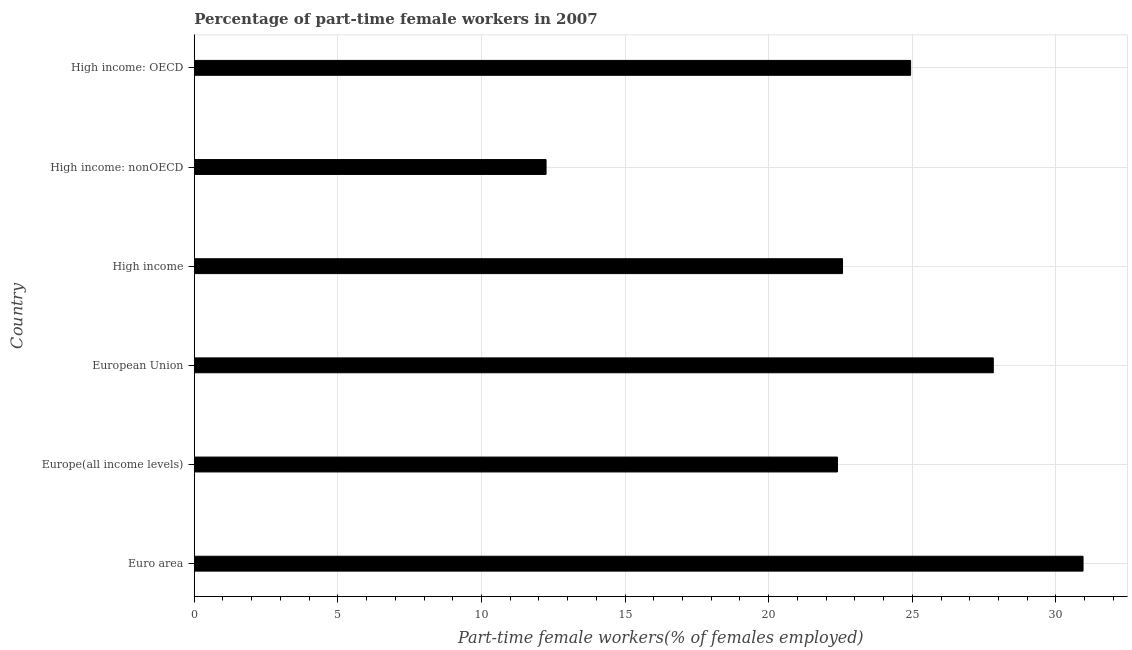Does the graph contain any zero values?
Make the answer very short. No. What is the title of the graph?
Make the answer very short. Percentage of part-time female workers in 2007. What is the label or title of the X-axis?
Your answer should be compact. Part-time female workers(% of females employed). What is the label or title of the Y-axis?
Ensure brevity in your answer.  Country. What is the percentage of part-time female workers in Euro area?
Your response must be concise. 30.95. Across all countries, what is the maximum percentage of part-time female workers?
Ensure brevity in your answer.  30.95. Across all countries, what is the minimum percentage of part-time female workers?
Provide a short and direct response. 12.25. In which country was the percentage of part-time female workers maximum?
Make the answer very short. Euro area. In which country was the percentage of part-time female workers minimum?
Provide a short and direct response. High income: nonOECD. What is the sum of the percentage of part-time female workers?
Make the answer very short. 140.92. What is the difference between the percentage of part-time female workers in Europe(all income levels) and High income: OECD?
Keep it short and to the point. -2.55. What is the average percentage of part-time female workers per country?
Keep it short and to the point. 23.49. What is the median percentage of part-time female workers?
Your answer should be compact. 23.76. What is the ratio of the percentage of part-time female workers in High income to that in High income: nonOECD?
Keep it short and to the point. 1.84. Is the percentage of part-time female workers in Euro area less than that in High income?
Make the answer very short. No. Is the difference between the percentage of part-time female workers in High income and High income: nonOECD greater than the difference between any two countries?
Your response must be concise. No. What is the difference between the highest and the second highest percentage of part-time female workers?
Provide a short and direct response. 3.12. Is the sum of the percentage of part-time female workers in High income and High income: nonOECD greater than the maximum percentage of part-time female workers across all countries?
Make the answer very short. Yes. In how many countries, is the percentage of part-time female workers greater than the average percentage of part-time female workers taken over all countries?
Your answer should be compact. 3. How many bars are there?
Offer a very short reply. 6. Are all the bars in the graph horizontal?
Give a very brief answer. Yes. What is the Part-time female workers(% of females employed) of Euro area?
Give a very brief answer. 30.95. What is the Part-time female workers(% of females employed) of Europe(all income levels)?
Provide a short and direct response. 22.39. What is the Part-time female workers(% of females employed) in European Union?
Ensure brevity in your answer.  27.82. What is the Part-time female workers(% of females employed) of High income?
Offer a very short reply. 22.57. What is the Part-time female workers(% of females employed) of High income: nonOECD?
Provide a succinct answer. 12.25. What is the Part-time female workers(% of females employed) in High income: OECD?
Ensure brevity in your answer.  24.94. What is the difference between the Part-time female workers(% of females employed) in Euro area and Europe(all income levels)?
Offer a very short reply. 8.55. What is the difference between the Part-time female workers(% of females employed) in Euro area and European Union?
Your answer should be compact. 3.13. What is the difference between the Part-time female workers(% of females employed) in Euro area and High income?
Provide a succinct answer. 8.37. What is the difference between the Part-time female workers(% of females employed) in Euro area and High income: nonOECD?
Give a very brief answer. 18.7. What is the difference between the Part-time female workers(% of females employed) in Euro area and High income: OECD?
Your answer should be compact. 6. What is the difference between the Part-time female workers(% of females employed) in Europe(all income levels) and European Union?
Ensure brevity in your answer.  -5.43. What is the difference between the Part-time female workers(% of females employed) in Europe(all income levels) and High income?
Provide a succinct answer. -0.18. What is the difference between the Part-time female workers(% of females employed) in Europe(all income levels) and High income: nonOECD?
Your response must be concise. 10.15. What is the difference between the Part-time female workers(% of females employed) in Europe(all income levels) and High income: OECD?
Provide a short and direct response. -2.55. What is the difference between the Part-time female workers(% of females employed) in European Union and High income?
Your answer should be compact. 5.25. What is the difference between the Part-time female workers(% of females employed) in European Union and High income: nonOECD?
Offer a very short reply. 15.57. What is the difference between the Part-time female workers(% of females employed) in European Union and High income: OECD?
Provide a short and direct response. 2.88. What is the difference between the Part-time female workers(% of females employed) in High income and High income: nonOECD?
Provide a short and direct response. 10.32. What is the difference between the Part-time female workers(% of females employed) in High income and High income: OECD?
Provide a succinct answer. -2.37. What is the difference between the Part-time female workers(% of females employed) in High income: nonOECD and High income: OECD?
Ensure brevity in your answer.  -12.69. What is the ratio of the Part-time female workers(% of females employed) in Euro area to that in Europe(all income levels)?
Offer a very short reply. 1.38. What is the ratio of the Part-time female workers(% of females employed) in Euro area to that in European Union?
Your response must be concise. 1.11. What is the ratio of the Part-time female workers(% of females employed) in Euro area to that in High income?
Keep it short and to the point. 1.37. What is the ratio of the Part-time female workers(% of females employed) in Euro area to that in High income: nonOECD?
Provide a short and direct response. 2.53. What is the ratio of the Part-time female workers(% of females employed) in Euro area to that in High income: OECD?
Provide a succinct answer. 1.24. What is the ratio of the Part-time female workers(% of females employed) in Europe(all income levels) to that in European Union?
Your answer should be compact. 0.81. What is the ratio of the Part-time female workers(% of females employed) in Europe(all income levels) to that in High income: nonOECD?
Keep it short and to the point. 1.83. What is the ratio of the Part-time female workers(% of females employed) in Europe(all income levels) to that in High income: OECD?
Offer a terse response. 0.9. What is the ratio of the Part-time female workers(% of females employed) in European Union to that in High income?
Provide a short and direct response. 1.23. What is the ratio of the Part-time female workers(% of females employed) in European Union to that in High income: nonOECD?
Your response must be concise. 2.27. What is the ratio of the Part-time female workers(% of females employed) in European Union to that in High income: OECD?
Offer a terse response. 1.11. What is the ratio of the Part-time female workers(% of females employed) in High income to that in High income: nonOECD?
Your response must be concise. 1.84. What is the ratio of the Part-time female workers(% of females employed) in High income to that in High income: OECD?
Ensure brevity in your answer.  0.91. What is the ratio of the Part-time female workers(% of females employed) in High income: nonOECD to that in High income: OECD?
Ensure brevity in your answer.  0.49. 